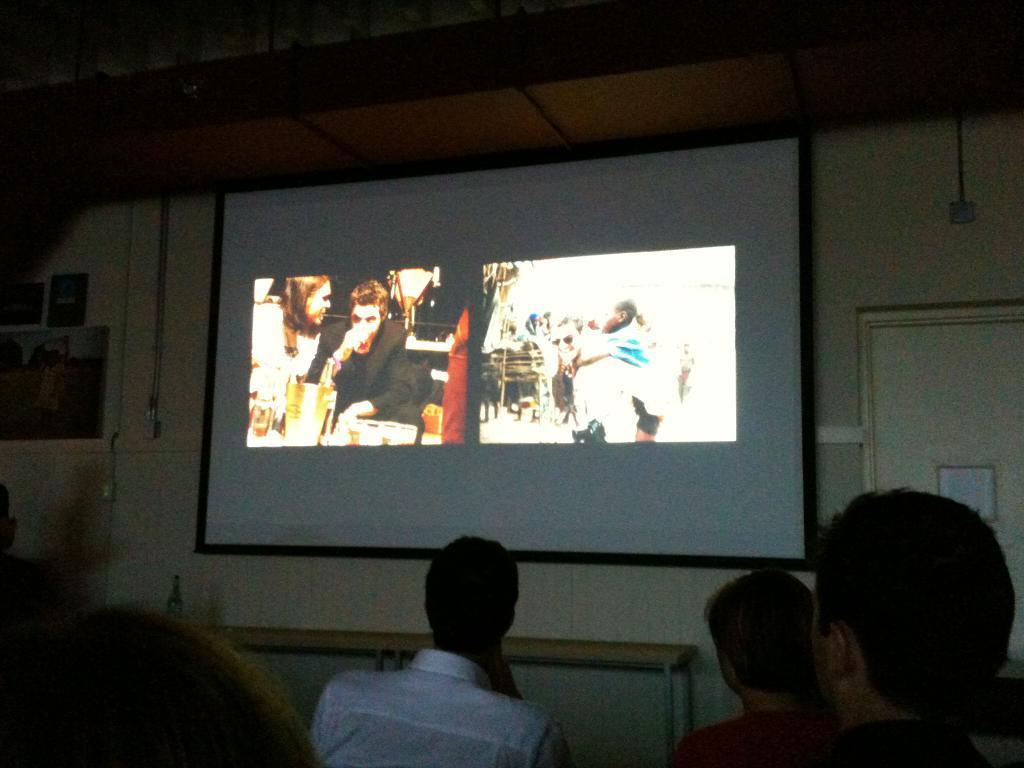Please provide a concise description of this image. In this image we can see a projector screen on the wall and few pictures are displayed on the screen and few people are watching it together. There is a wall on right to the projector screen and a photo on the left to the projector screen. 